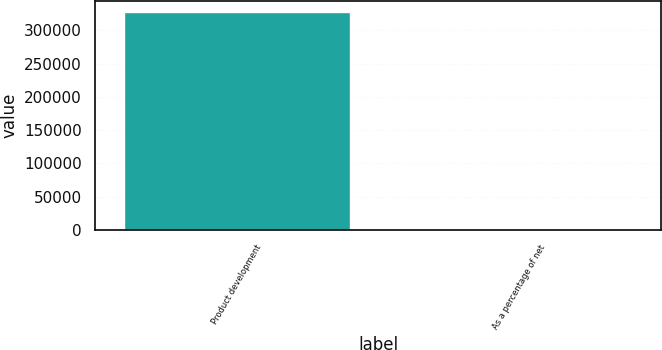<chart> <loc_0><loc_0><loc_500><loc_500><bar_chart><fcel>Product development<fcel>As a percentage of net<nl><fcel>328191<fcel>7.2<nl></chart> 